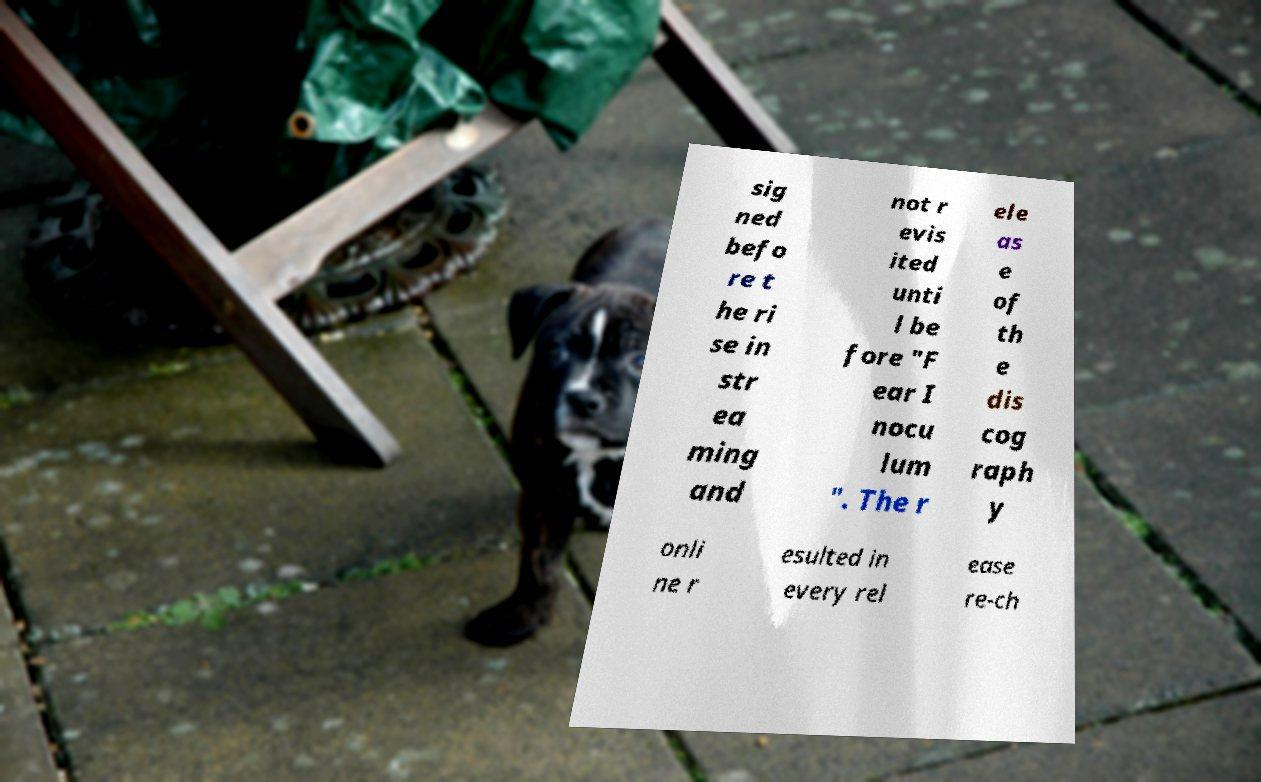Could you extract and type out the text from this image? sig ned befo re t he ri se in str ea ming and not r evis ited unti l be fore "F ear I nocu lum ". The r ele as e of th e dis cog raph y onli ne r esulted in every rel ease re-ch 